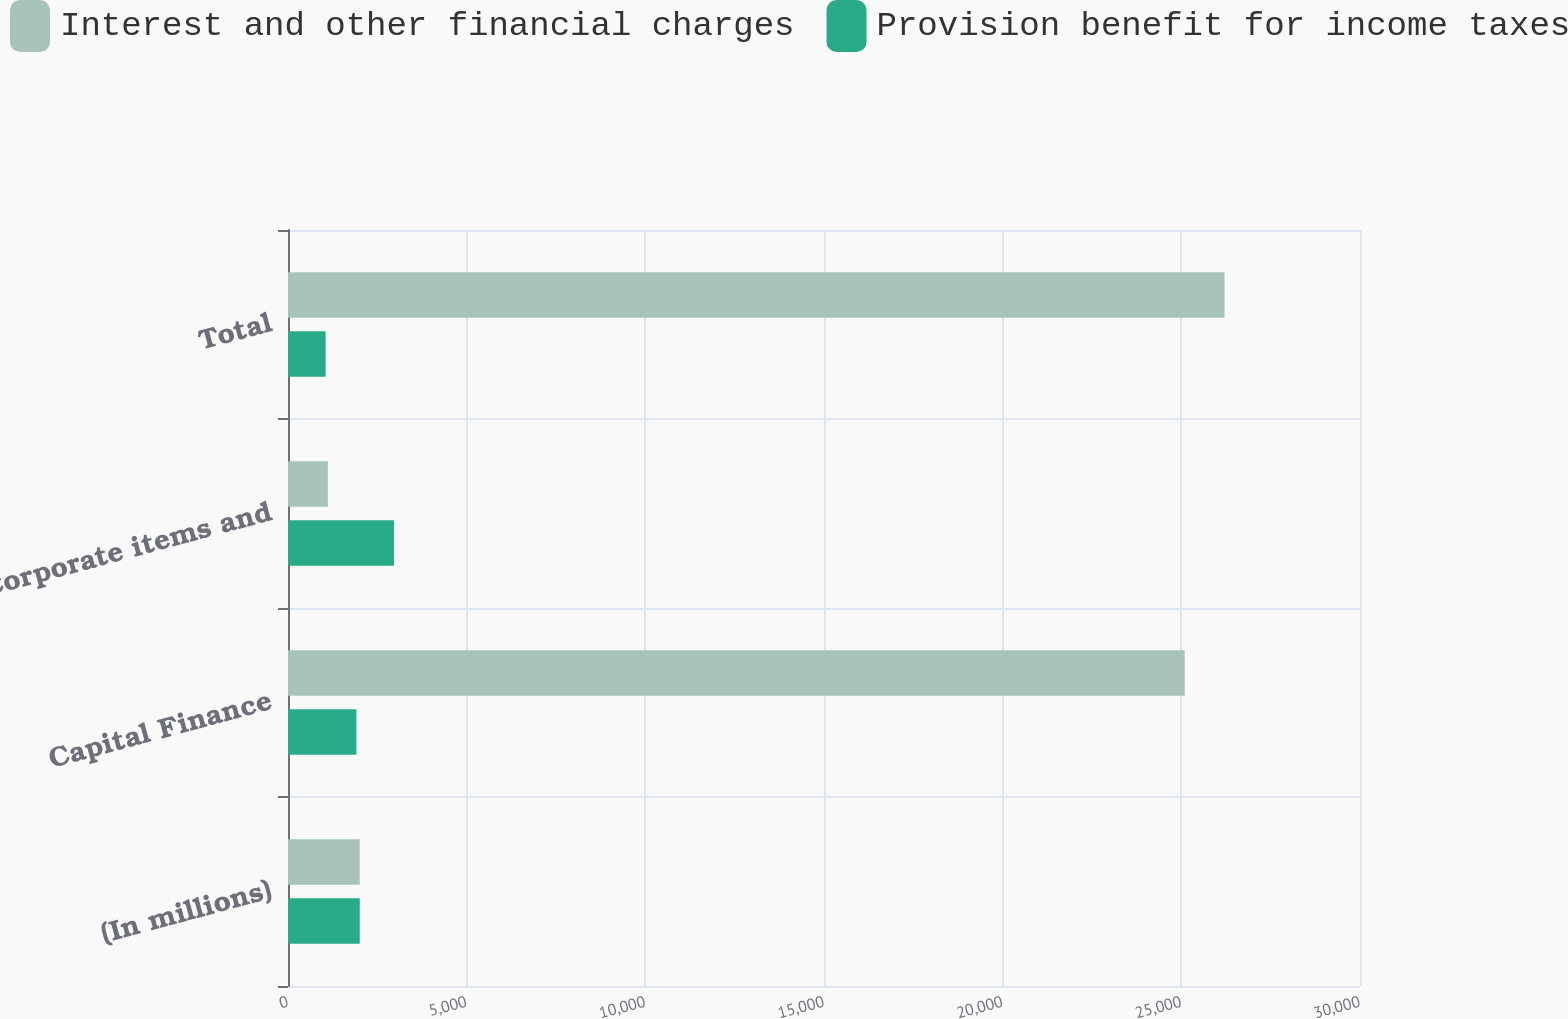Convert chart. <chart><loc_0><loc_0><loc_500><loc_500><stacked_bar_chart><ecel><fcel>(In millions)<fcel>Capital Finance<fcel>Corporate items and<fcel>Total<nl><fcel>Interest and other financial charges<fcel>2008<fcel>25094<fcel>1115<fcel>26209<nl><fcel>Provision benefit for income taxes<fcel>2008<fcel>1914<fcel>2966<fcel>1052<nl></chart> 